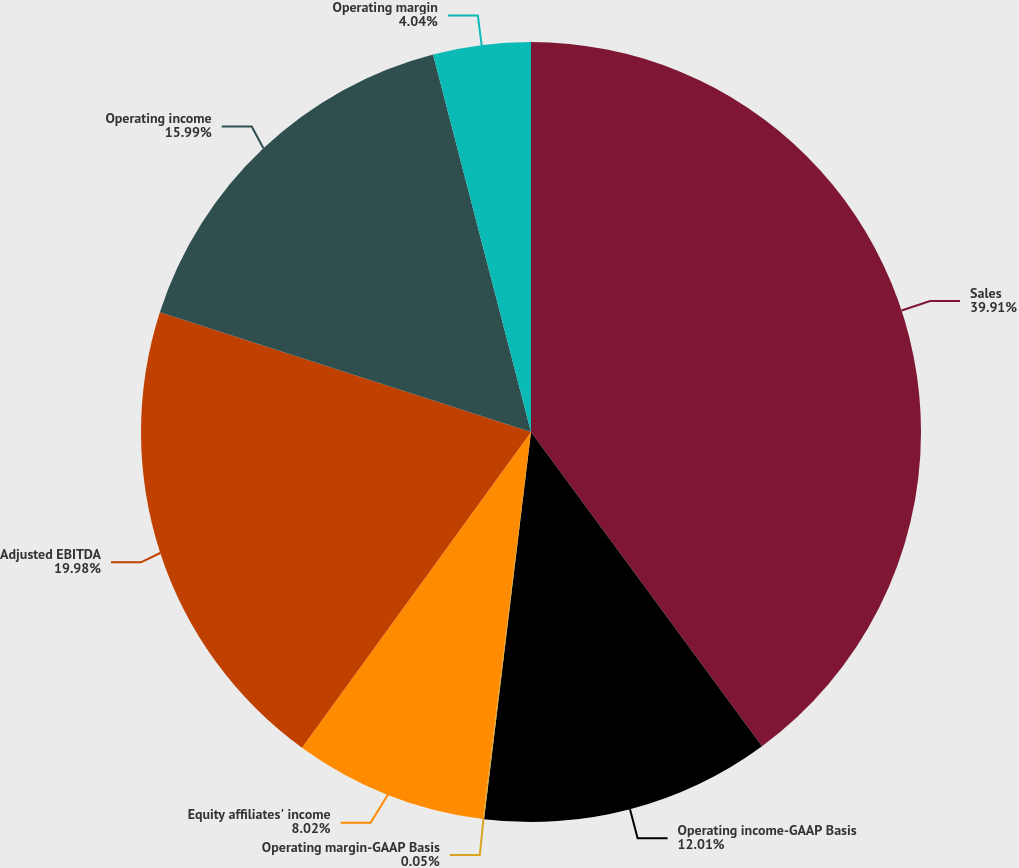Convert chart. <chart><loc_0><loc_0><loc_500><loc_500><pie_chart><fcel>Sales<fcel>Operating income-GAAP Basis<fcel>Operating margin-GAAP Basis<fcel>Equity affiliates' income<fcel>Adjusted EBITDA<fcel>Operating income<fcel>Operating margin<nl><fcel>39.91%<fcel>12.01%<fcel>0.05%<fcel>8.02%<fcel>19.98%<fcel>15.99%<fcel>4.04%<nl></chart> 